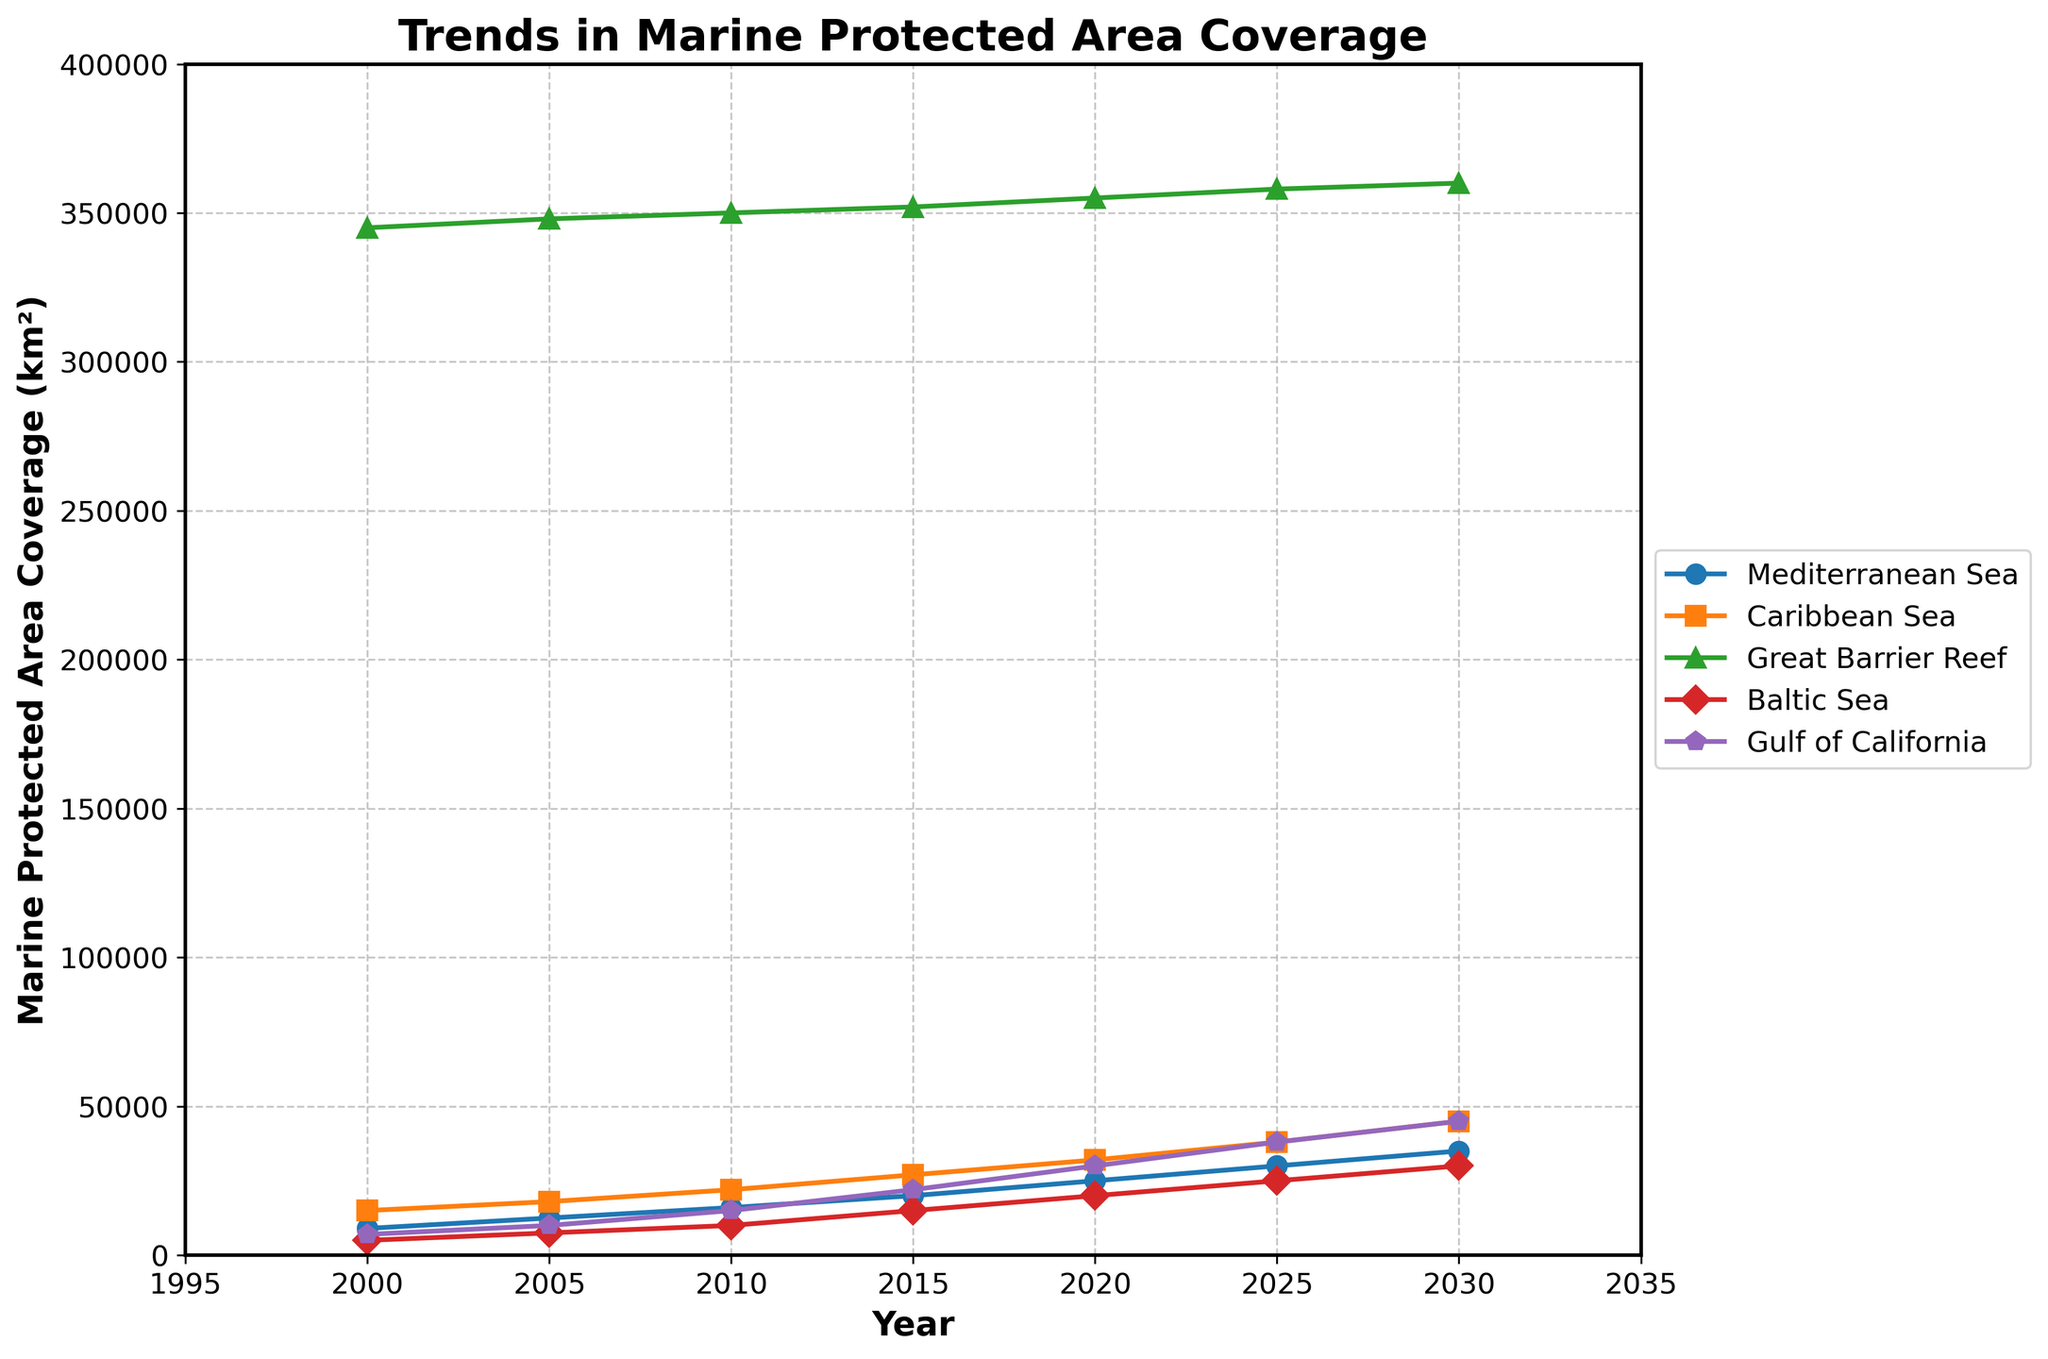What is the trend in marine protected area coverage for the Great Barrier Reef from 2000 to 2030? The Great Barrier Reef shows a consistent increase in marine protected area coverage from 345,000 km² in 2000 to 360,000 km² in 2030. Each data point on the line plot indicates an increase over time.
Answer: Consistently increasing Which coastal region had the greatest increase in marine protected area coverage between 2000 and 2030? To determine the greatest increase, we need to calculate the difference for each region between 2000 and 2030. The Caribbean Sea increased by 30,000 km², Great Barrier Reef by 15,000 km², Baltic Sea by 25,000 km², Gulf of California by 38,000 km², and Mediterranean Sea by 26,000 km². The Gulf of California had the greatest increase.
Answer: Gulf of California In 2015, which coastal region had the largest marine protected area coverage? The line plot for 2015 shows the Great Barrier Reef with 352,000 km², which is the highest value among all the regions for that year.
Answer: Great Barrier Reef How does the marine protected area coverage in the Mediterranean Sea in 2025 compare to that in the Baltic Sea in 2025? By looking at the values on the plot for 2025, the Mediterranean Sea has 30,000 km², while the Baltic Sea has 25,000 km². Thus, the Mediterranean Sea's coverage is 5,000 km² more than the Baltic Sea's coverage in 2025.
Answer: Mediterranean Sea has 5,000 km² more What is the total marine protected area coverage of all regions combined in 2020? Sum the coverage for all regions in 2020: 25,000 (Mediterranean Sea) + 32,000 (Caribbean Sea) + 355,000 (Great Barrier Reef) + 20,000 (Baltic Sea) + 30,000 (Gulf of California) = 462,000 km².
Answer: 462,000 km² Which regions experienced the biggest change in coverage from 2000 to 2020? We need to look at the difference in values between 2000 and 2020. Mediterranean Sea: 16,000 km², Caribbean Sea: 17,000 km², Great Barrier Reef: 10,000 km², Baltic Sea: 15,000 km², and Gulf of California: 23,000 km². The Gulf of California experienced the biggest change.
Answer: Gulf of California In what year does the Caribbean Sea's marine protected area coverage exceed 40,000 km²? Look at the trend line for the Caribbean Sea. The coverage exceeds 40,000 km² in 2030.
Answer: 2030 Compare the rate of increase in protected area coverage between the Mediterranean Sea and the Gulf of California from 2005 to 2025. For the Mediterranean Sea: from 12,500 km² to 30,000 km², an increase of 17,500 km² over 20 years. For the Gulf of California: from 10,000 km² to 38,000 km², an increase of 28,000 km² over the same period. The Gulf of California's rate of increase is greater.
Answer: Gulf of California has a greater rate of increase By how much did the marine protected area coverage in the Baltic Sea increase from 2010 to 2025? Subtract the value in 2010 from that in 2025: 25,000 km² (2025) - 10,000 km² (2010) = 15,000 km².
Answer: 15,000 km² What is the average annual increase in marine protected area coverage for the Gulf of California from 2000 to 2030? First, find the total increase: 45,000 km² (2030) - 7,000 km² (2000) = 38,000 km². Then divide by the number of years: 38,000 km² / 30 years ≈ 1,267 km² per year.
Answer: 1,267 km² per year 